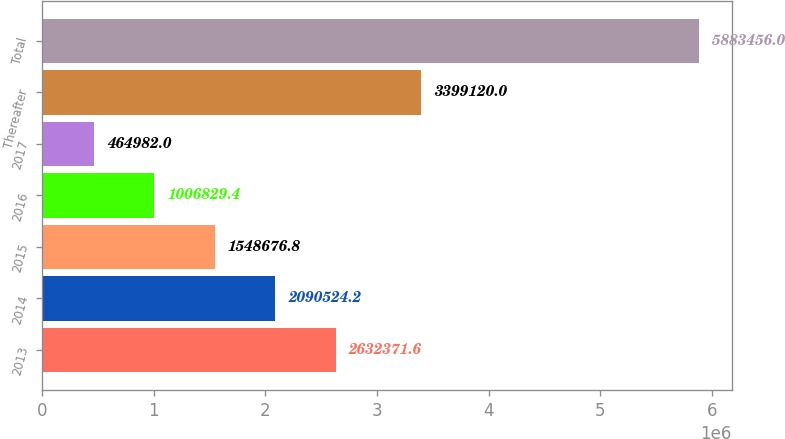<chart> <loc_0><loc_0><loc_500><loc_500><bar_chart><fcel>2013<fcel>2014<fcel>2015<fcel>2016<fcel>2017<fcel>Thereafter<fcel>Total<nl><fcel>2.63237e+06<fcel>2.09052e+06<fcel>1.54868e+06<fcel>1.00683e+06<fcel>464982<fcel>3.39912e+06<fcel>5.88346e+06<nl></chart> 